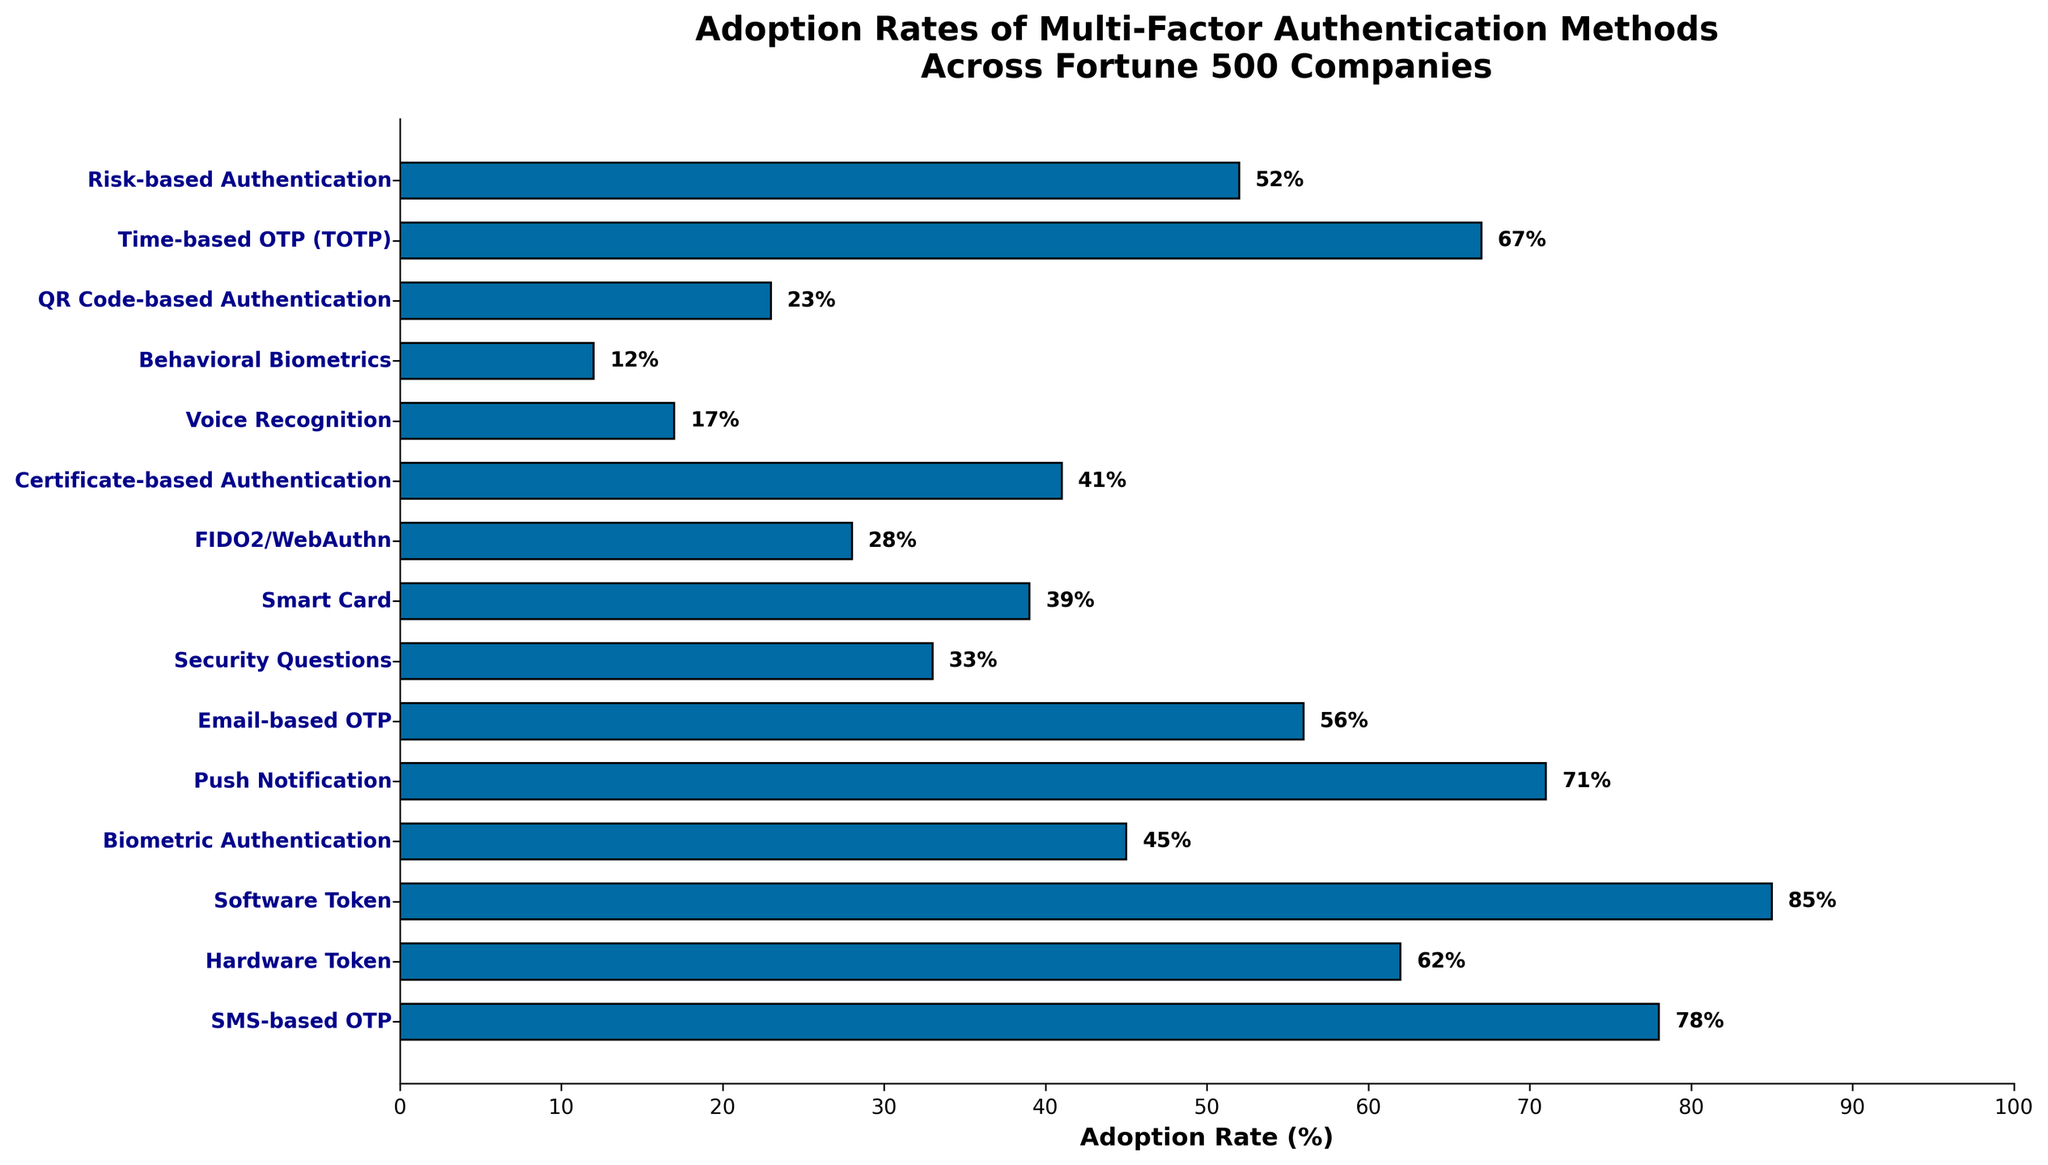How many MFA methods have an adoption rate higher than 50%? There are 8 MFA methods with adoption rates higher than 50%, which are SMS-based OTP (78%), Hardware Token (62%), Software Token (85%), Push Notification (71%), Email-based OTP (56%), Time-based OTP (TOTP) (67%), and Risk-based Authentication (52%).
Answer: 8 Which MFA method has the lowest adoption rate among the Fortune 500 companies? Behavioral Biometrics has the lowest adoption rate at 12%. This can be identified by noting the shortest bar on the chart.
Answer: Behavioral Biometrics Compare the adoption rates of Software Token and Biometric Authentication. Which one is higher and by how much? Software Token has an adoption rate of 85%, while Biometric Authentication has an adoption rate of 45%. By subtracting the lower rate from the higher rate, we find that Software Token is adopted 40% more than Biometric Authentication.
Answer: Software Token, 40% Which MFA methods have adoption rates between 30% and 40%? The methods with adoption rates between 30% and 40% are: Security Questions (33%) and Smart Card (39%). This can be seen by looking at the lengths of the bars that fall in the 30-40% range.
Answer: Security Questions, Smart Card What's the difference in adoption rates between the most and least adopted MFA methods? The most adopted method is Software Token at 85%, and the least adopted is Behavioral Biometrics at 12%. The difference can be found by subtracting 12% from 85%, which equals 73%.
Answer: 73% What is the average adoption rate of all the MFA methods displayed? Summing all adoption rates: 78 + 62 + 85 + 45 + 71 + 56 + 33 + 39 + 28 + 41 + 17 + 12 + 23 + 67 + 52 = 709%. There are 15 methods, so the average adoption rate is 709 / 15 ≈ 47.27%.
Answer: 47.27% Identify the MFA methods with adoption rates that are equal to or greater than 70%. The methods with adoption rates equal to or greater than 70% are: SMS-based OTP (78%), Software Token (85%), and Push Notification (71%). This can be identified by visually inspecting the longer bars.
Answer: SMS-based OTP, Software Token, Push Notification Compare the visual lengths of the bars representing FIDO2/WebAuthn and Smart Card. Which one appears longer, and what might this indicate about their adoption rates? The bar for Smart Card (39%) is visually longer than that for FIDO2/WebAuthn (28%). This indicates that Smart Card has a higher adoption rate compared to FIDO2/WebAuthn.
Answer: Smart Card Between Certificate-based Authentication and Time-based OTP (TOTP), which method has a higher adoption rate and by how much? Time-based OTP (TOTP) has an adoption rate of 67%, whereas Certificate-based Authentication has an adoption rate of 41%. The difference can be calculated as 67 - 41 = 26%.
Answer: Time-based OTP (TOTP), 26% What is the combined adoption rate of Email-based OTP and Push Notification? The adoption rate for Email-based OTP is 56% and for Push Notification is 71%. Adding these together gives 56 + 71 = 127%.
Answer: 127% 